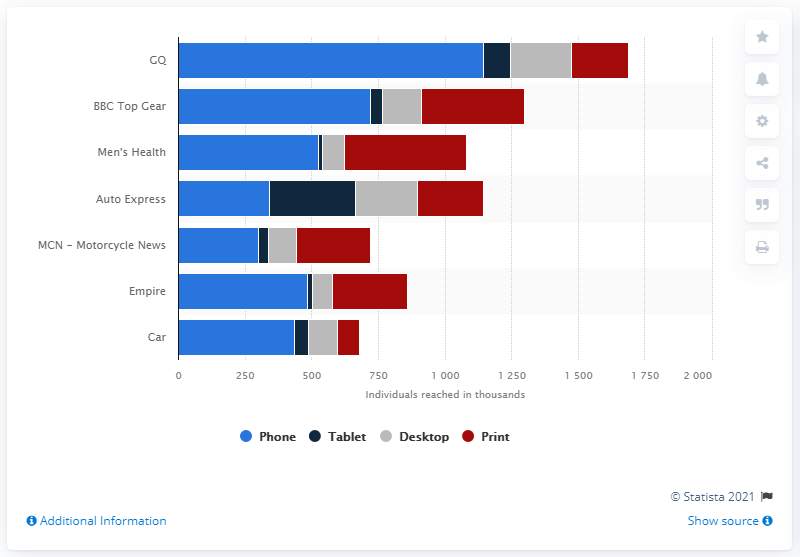Identify some key points in this picture. GQ was the leading men's magazine in the UK from April 2019 to March 2020. 